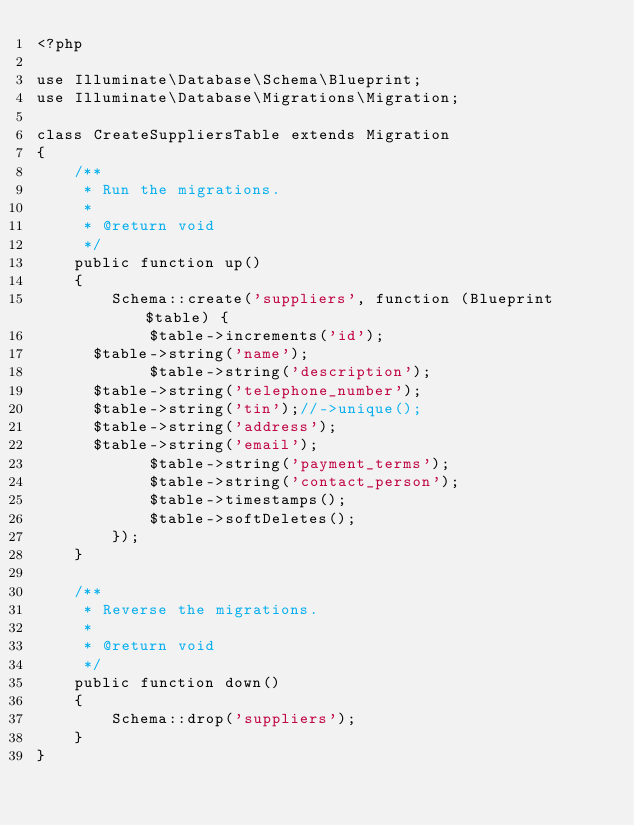<code> <loc_0><loc_0><loc_500><loc_500><_PHP_><?php

use Illuminate\Database\Schema\Blueprint;
use Illuminate\Database\Migrations\Migration;

class CreateSuppliersTable extends Migration
{
    /**
     * Run the migrations.
     *
     * @return void
     */
    public function up()
    {
        Schema::create('suppliers', function (Blueprint $table) {
            $table->increments('id');
			$table->string('name');
            $table->string('description');
			$table->string('telephone_number');
			$table->string('tin');//->unique();
			$table->string('address');
			$table->string('email');
            $table->string('payment_terms');
            $table->string('contact_person');
            $table->timestamps();
            $table->softDeletes();
        });
    }

    /**
     * Reverse the migrations.
     *
     * @return void
     */
    public function down()
    {
        Schema::drop('suppliers');
    }
}
</code> 